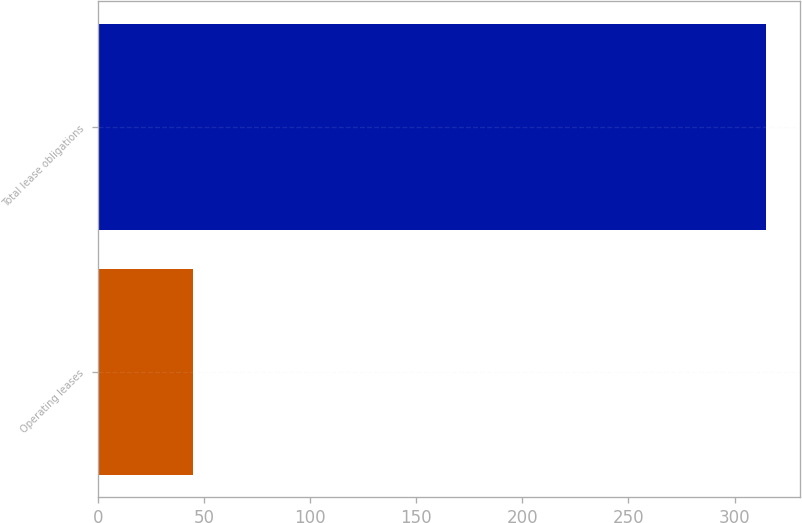Convert chart. <chart><loc_0><loc_0><loc_500><loc_500><bar_chart><fcel>Operating leases<fcel>Total lease obligations<nl><fcel>45<fcel>315<nl></chart> 